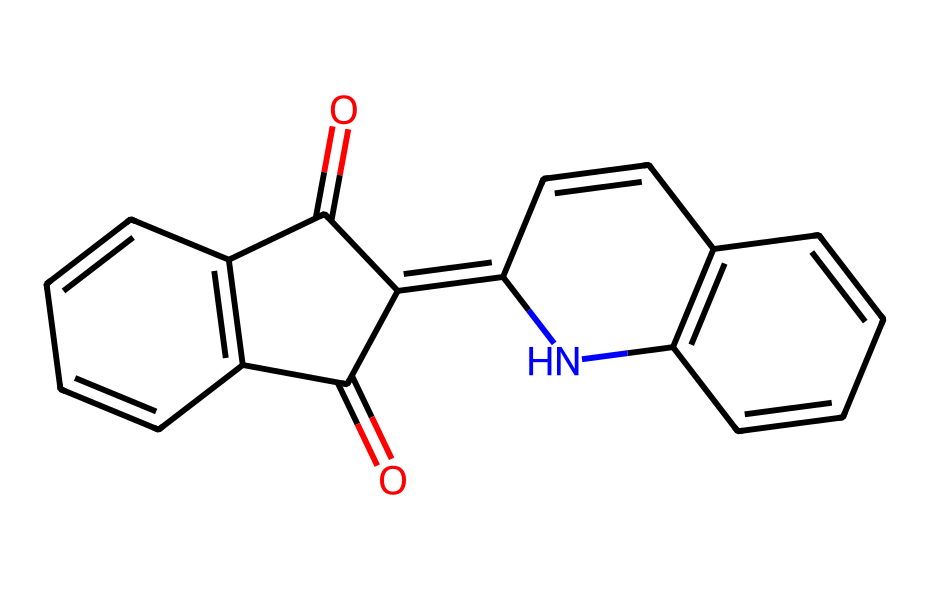How many carbon atoms are present in this compound? By examining the SMILES notation, we count the number of carbon (C) characters. Each "C" represents a carbon atom. In this structure, there are 16 "C" characters present.
Answer: 16 What functional groups are present in the indigo structure? The presence of carbonyl groups is identified by the "=O" notation in the SMILES. Counting these occurrences shows two carbonyl (C=O) functional groups.
Answer: carbonyl What is the molecular formula for this compound? To derive the molecular formula, we derive the counts of carbon (C), hydrogen (H), nitrogen (N), and oxygen (O) atoms from the SMILES notation. Thus, the counts yield C16H10N2O2.
Answer: C16H10N2O2 Which atom indicates the presence of nitrogen in this molecule? The nitrogen atom is denoted as "N" in the SMILES representation. By checking for the "N" character, it's confirmed that nitrogen is present twice in this structure.
Answer: nitrogen Is this molecule an aromatic compound? By analyzing the structure, specifically the presence of conjugated double bonds, we can identify that this compound contains a planar, cyclic structure that allows for resonance, confirming its aromatic nature.
Answer: yes 